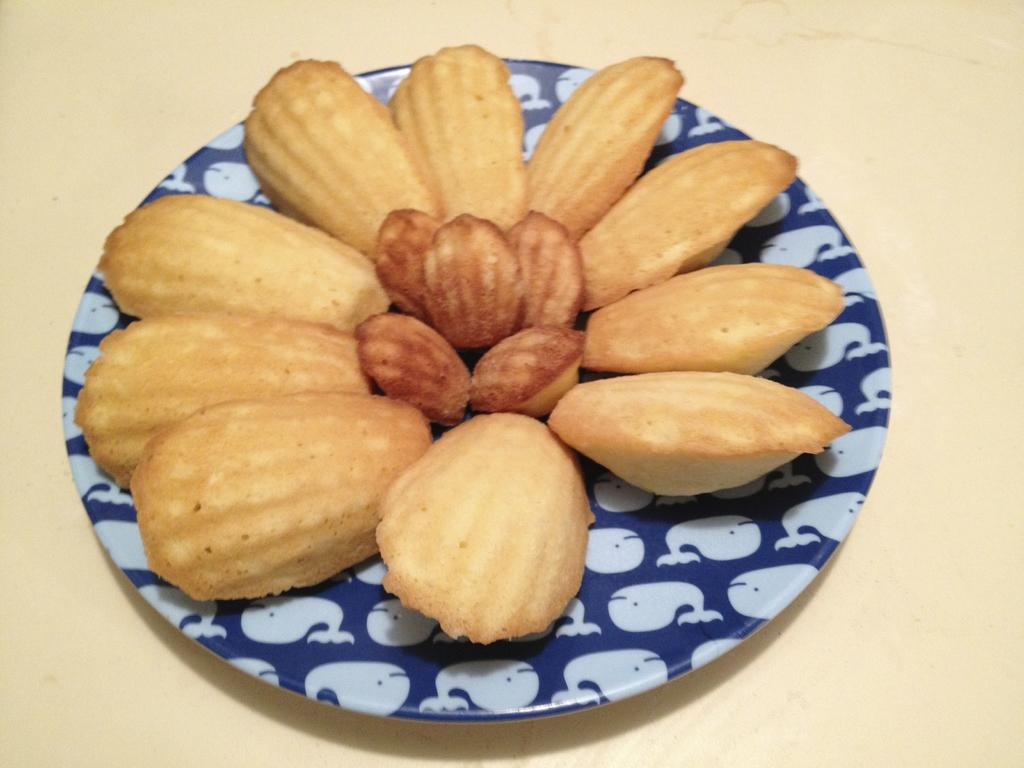What type of food item is on the platter in the image? There is a snack item on a platter in the image. What is the color or material of the surface the platter is on? The platter is on a cream surface. What type of liquid is being poured onto the snack item in the image? There is no liquid being poured onto the snack item in the image. What type of vest is visible on the platter in the image? There is no vest present in the image; it only features a snack item on a platter. 